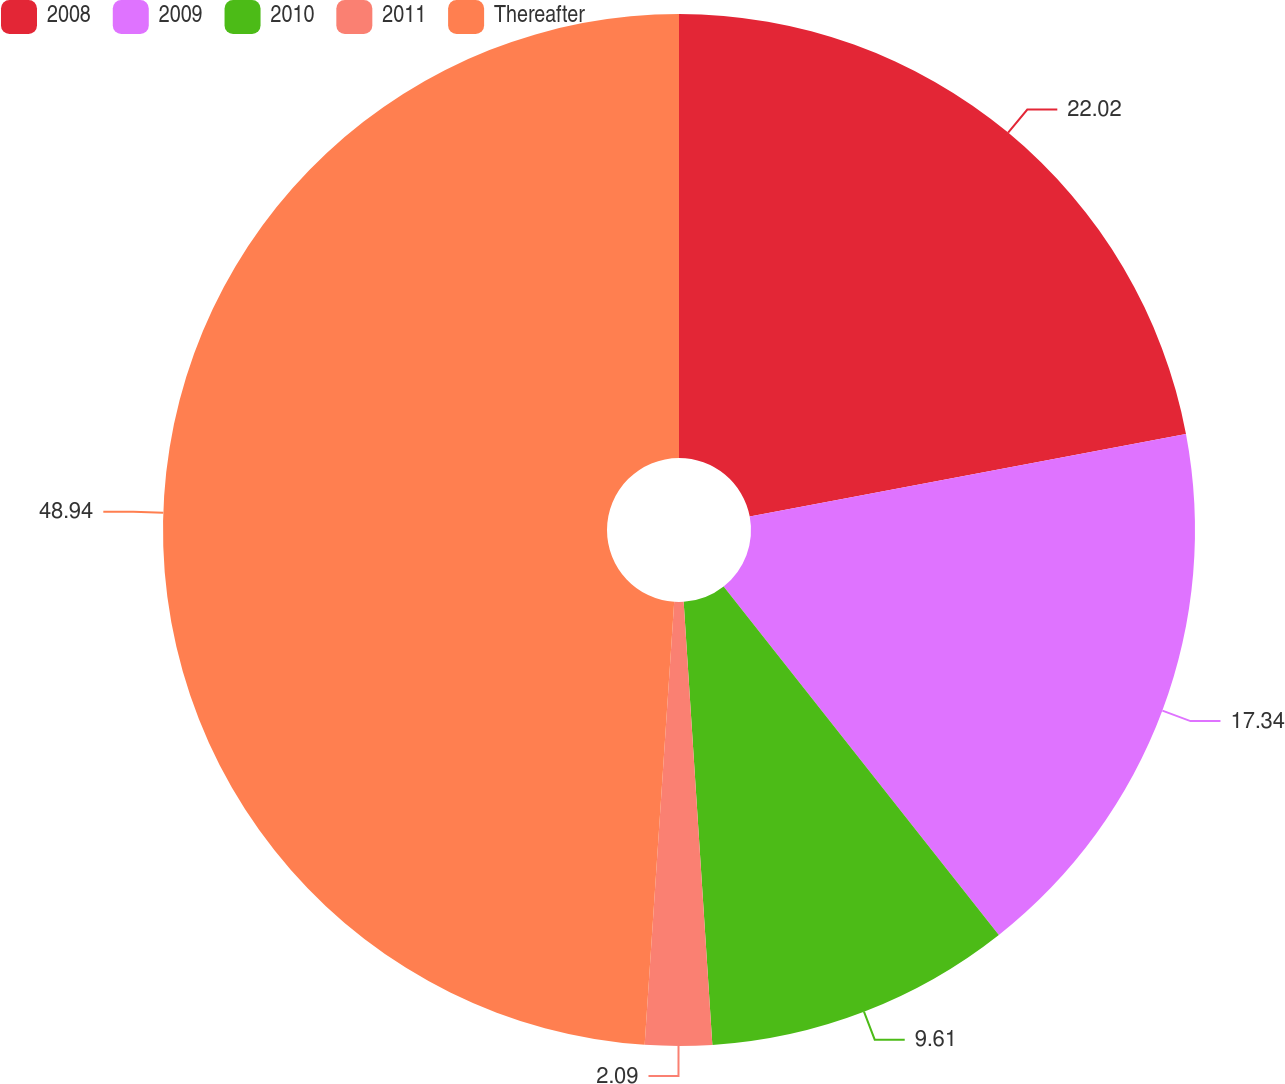Convert chart. <chart><loc_0><loc_0><loc_500><loc_500><pie_chart><fcel>2008<fcel>2009<fcel>2010<fcel>2011<fcel>Thereafter<nl><fcel>22.02%<fcel>17.34%<fcel>9.61%<fcel>2.09%<fcel>48.94%<nl></chart> 